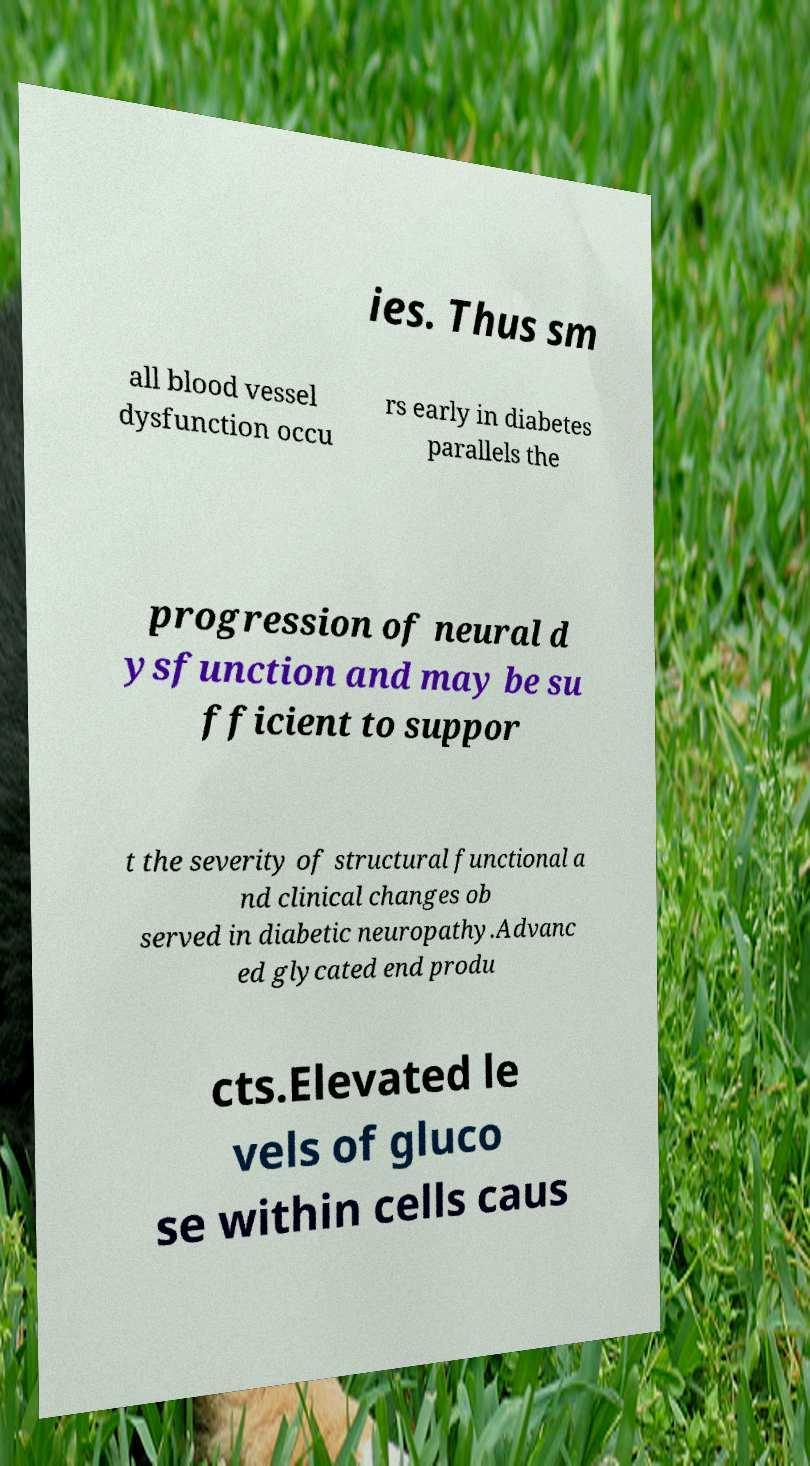There's text embedded in this image that I need extracted. Can you transcribe it verbatim? ies. Thus sm all blood vessel dysfunction occu rs early in diabetes parallels the progression of neural d ysfunction and may be su fficient to suppor t the severity of structural functional a nd clinical changes ob served in diabetic neuropathy.Advanc ed glycated end produ cts.Elevated le vels of gluco se within cells caus 